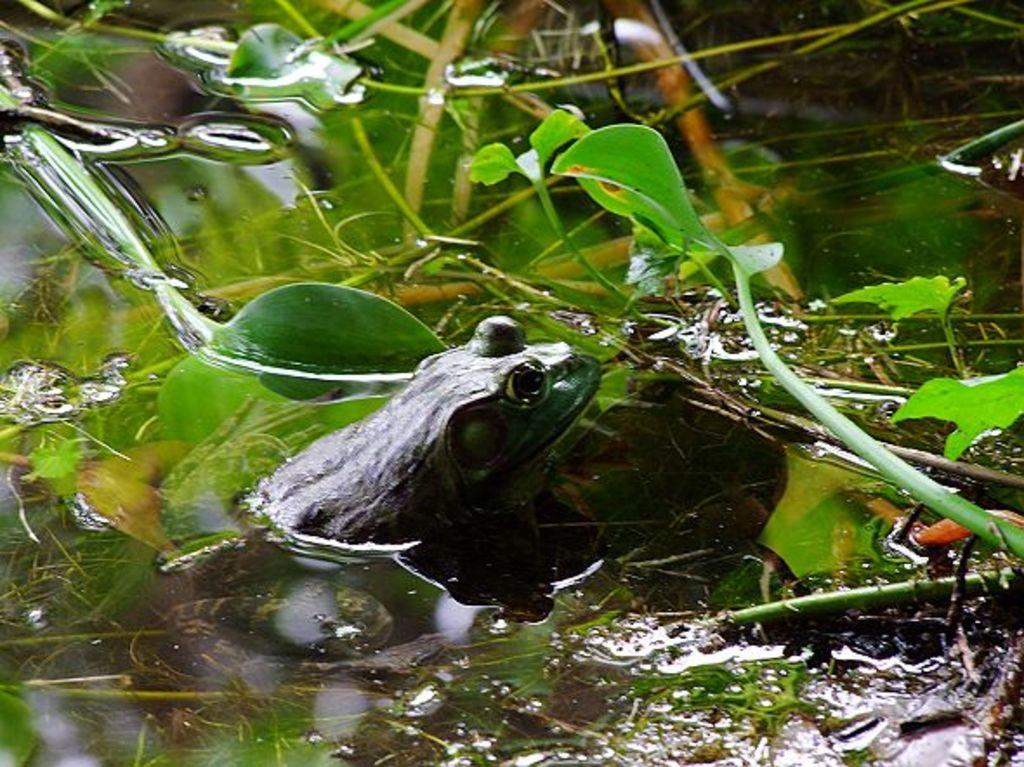What animal is present in the image? There is a frog in the image. Where is the frog located? The frog is in the water. What type of body of water might the frog be in? The water might be in a pond. What is in front of the frog? There is a creeper plant in front of the frog. What type of plants can be seen in the image? There are aquatic plants in the image. How many balls can be seen rolling on the side of the pond in the image? There are no balls present in the image, and the image does not show the side of the pond. 